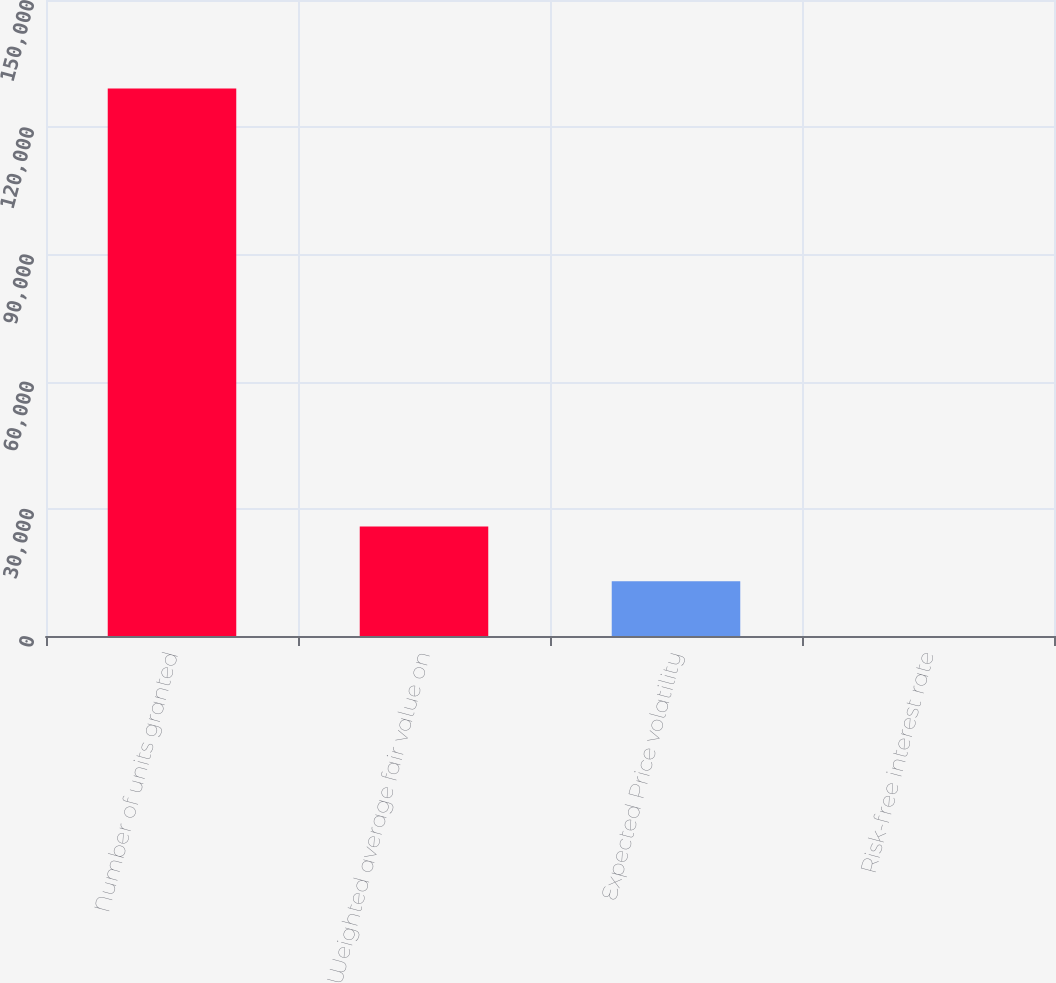<chart> <loc_0><loc_0><loc_500><loc_500><bar_chart><fcel>Number of units granted<fcel>Weighted average fair value on<fcel>Expected Price volatility<fcel>Risk-free interest rate<nl><fcel>129150<fcel>25830.5<fcel>12915.6<fcel>0.63<nl></chart> 